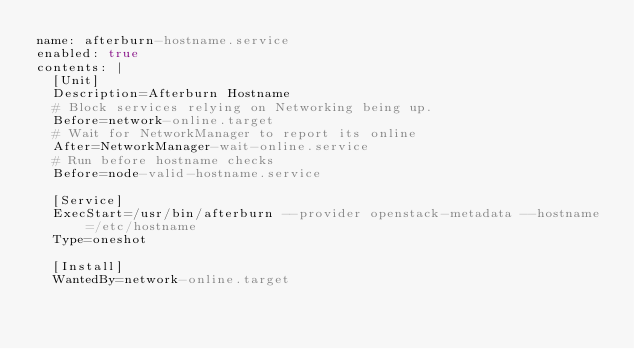<code> <loc_0><loc_0><loc_500><loc_500><_YAML_>name: afterburn-hostname.service
enabled: true
contents: |
  [Unit]
  Description=Afterburn Hostname
  # Block services relying on Networking being up.
  Before=network-online.target
  # Wait for NetworkManager to report its online
  After=NetworkManager-wait-online.service
  # Run before hostname checks
  Before=node-valid-hostname.service

  [Service]
  ExecStart=/usr/bin/afterburn --provider openstack-metadata --hostname=/etc/hostname
  Type=oneshot

  [Install]
  WantedBy=network-online.target
</code> 